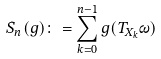Convert formula to latex. <formula><loc_0><loc_0><loc_500><loc_500>S _ { n } ( g ) \colon = \sum _ { k = 0 } ^ { n - 1 } g ( T _ { X _ { k } } \omega )</formula> 